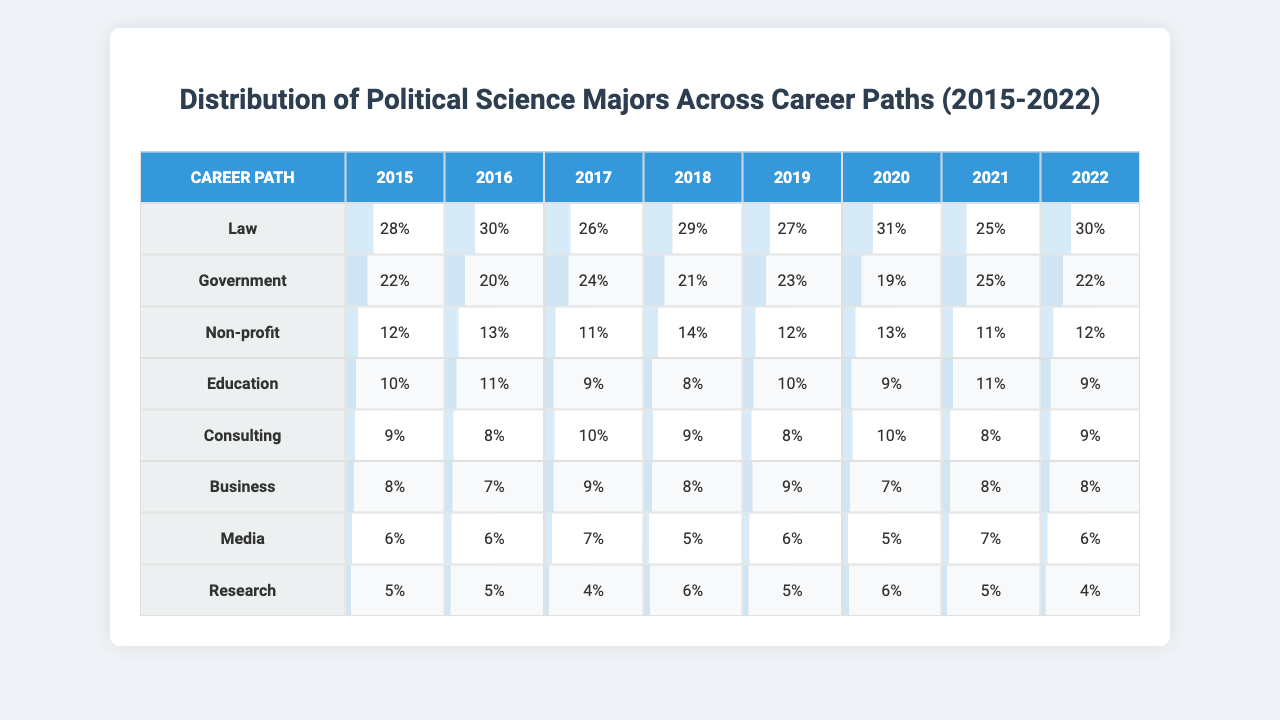What's the career path with the highest percentage of graduates in 2015? Looking at the first row of the table for 2015, the highest percentage is 28% for the Law career path.
Answer: Law What percentage of political science majors went into Education in 2018? In the row for 2018, the percentage for Education is 8%.
Answer: 8% What was the average percentage of graduates entering Non-profit careers from 2015 to 2022? Adding the Non-profit percentages from each year: (12 + 13 + 11 + 14 + 12 + 13 + 11 + 12) =  12.5. Then dividing by 8 gives an average of 12.5%.
Answer: 12.5% Did more than 30% of political science majors enter Business in any year from 2015 to 2022? The highest percentage for Business is 10% recorded in the years 2015-2022, which is less than 30%. Therefore, the answer is no.
Answer: No Which year had the highest representation of graduates in Research, and what was the percentage? Looking through each year for Research, 2016 had the highest at 6%.
Answer: 6% in 2016 What is the difference in percentage of graduates entering Government between 2015 and 2020? The percentage for Government in 2015 is 22%, and in 2020 it is 19%. The difference is 22 - 19 = 3%.
Answer: 3% What is the trend observed in the percentage of graduates entering Media from 2015 to 2022? Reviewing the Media percentages from 2015 to 2022 shows a fluctuating trend: 6% in 2015, 6% in 2016, decreasing to 5% in 2020 and 2022, indicating a decline.
Answer: Decline Which career path consistently had the lowest percentage of graduates across all years? Checking each year's lowest percentage, Media always has 5% or 6%, making it the lowest across all years.
Answer: Media How does the percentage of graduates entering Consulting in 2019 compare to the percentage in 2021? In 2019, the percentage for Consulting is 8%, while in 2021 it is 5%. The comparison shows a decrease of 3%.
Answer: Decrease of 3% 